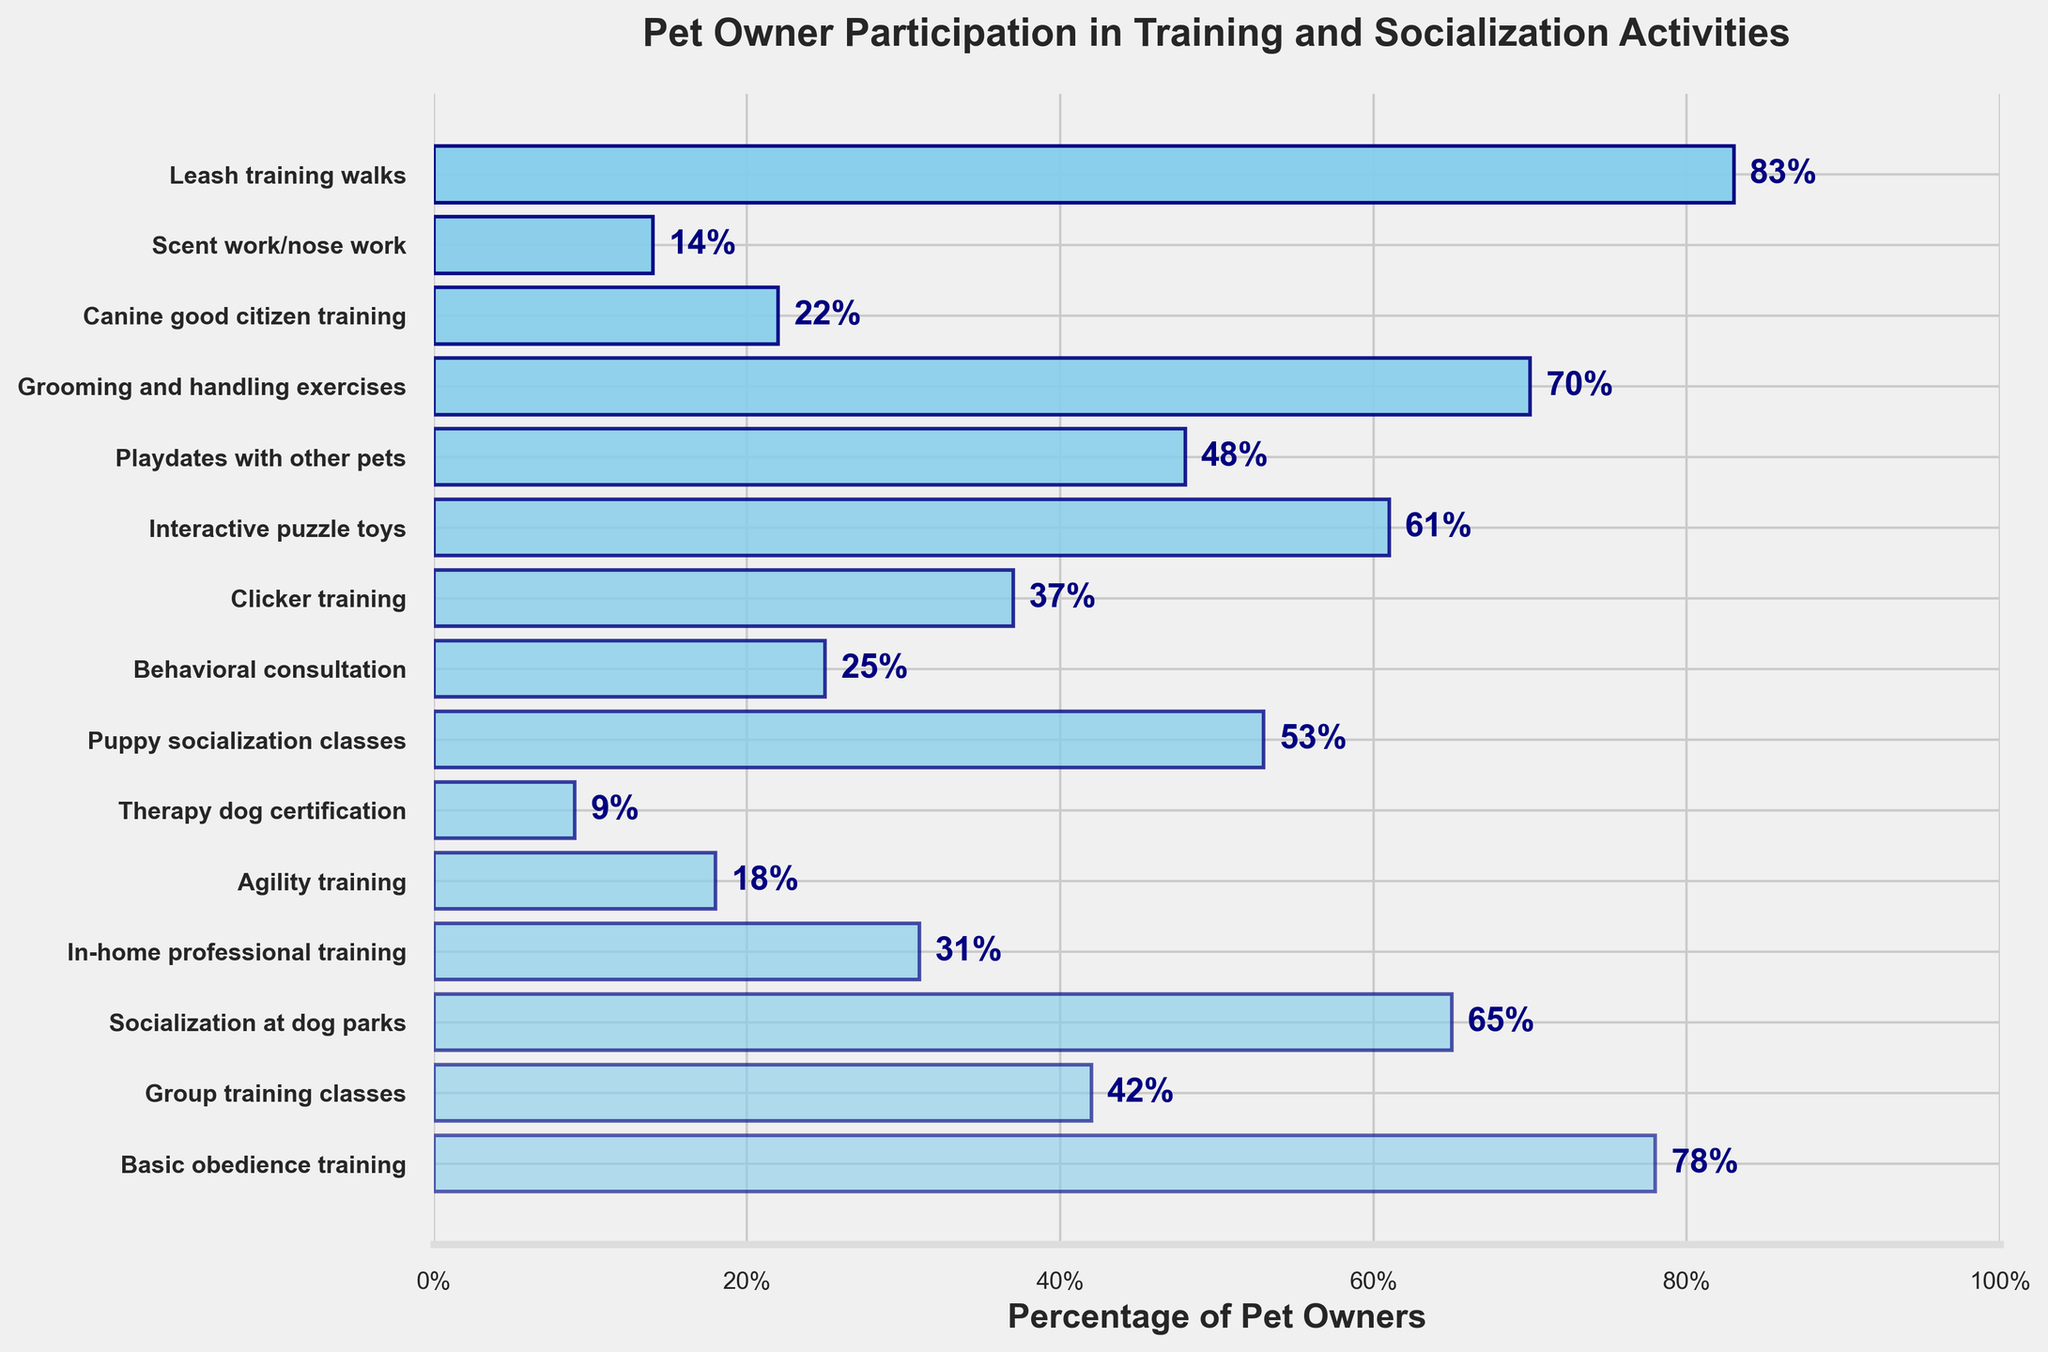What is the activity with the highest participation percentage? The figure shows multiple bars representing different activities, and the longest bar corresponds to "Leash training walks" with a percentage of 83.
Answer: Leash training walks Which activity has the lowest participation percentage? By observing the smallest bar in the figure, the activity with the lowest participation rate is "Therapy dog certification" at 9%.
Answer: Therapy dog certification How many activities have a participation percentage above 50%? Look at the bars where the percentage is greater than 50%. These activities are Basic obedience training (78), Socialization at dog parks (65), Puppy socialization classes (53), Interactive puzzle toys (61), Playdates with other pets (48), and Grooming and handling exercises (70) which gives us six activities.
Answer: Six What’s the percentage difference between Basic obedience training and Agility training? Basic obedience training has a percentage of 78 and Agility training is at 18. The difference can be calculated as 78 - 18.
Answer: 60 Which activities have a percentage between 20% and 40%? Look at the bars that fall within the range of 20% to 40%. These activities include Group training classes (42), Clicker training (37), Canine good citizen training (22), and Behavioral consultation (25).
Answer: Four: Group training classes, Clicker training, Canine good citizen training, Behavioral consultation Arrange the top three activities in descending order by percentage. The three activities with the highest percentages are Leash training walks (83), Basic obedience training (78), and Grooming and handling exercises (70). Arrange them as 83%, 78%, 70%.
Answer: Leash training walks, Basic obedience training, Grooming and handling exercises What is the difference in percentage between Socialization at dog parks and Playdates with other pets? Socialization at dog parks is at 65%, while Playdates with other pets is 48%. The difference is 65 - 48.
Answer: 17 Name two activities with the closest participation percentages. The two closest values among the given data are Group training classes (42%) and Clicker training (37%), with a difference of only 5%.
Answer: Group training classes and Clicker training What is the average participation percentage for Behavioral consultation, Clicker training, and Scent work/nose work? Add the percentages 25, 37, and 14. Then, divide by 3 to find the average. (25 + 37 + 14) / 3 = 76 / 3.
Answer: 25.33 How many activities have a participation percentage below the median value? First, list percentages in ascending order: 9, 14, 18, 22, 25, 31, 37, 42, 48, 53, 61, 65, 70, 78, 83. With 15 activities, the median value (8th item) is 42. Six activities are below 42: Therapy dog certification (9), Scent work/nose work (14), Agility training (18), Canine good citizen training (22), Behavioral consultation (25), In-home professional training (31).
Answer: Six 